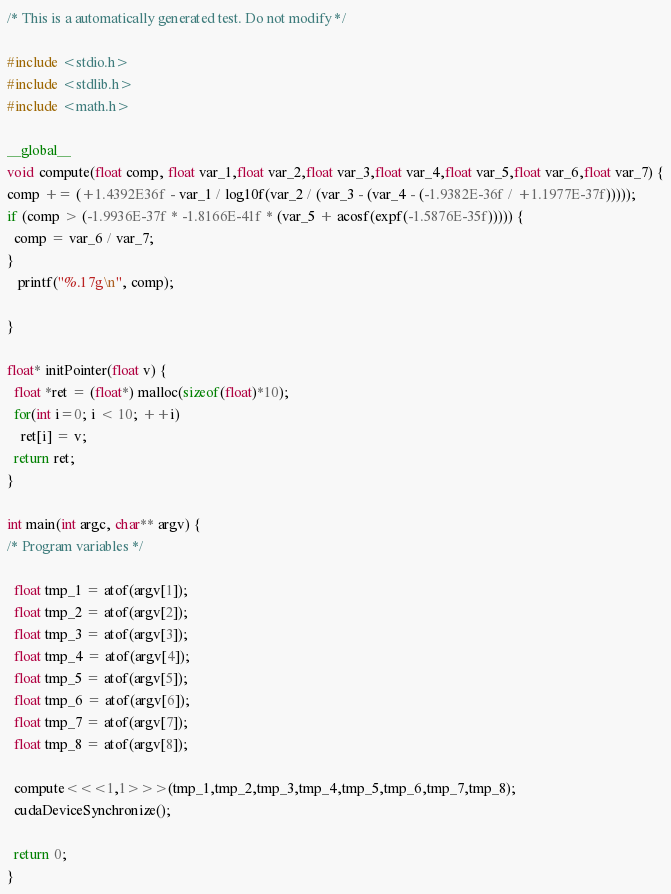Convert code to text. <code><loc_0><loc_0><loc_500><loc_500><_Cuda_>
/* This is a automatically generated test. Do not modify */

#include <stdio.h>
#include <stdlib.h>
#include <math.h>

__global__
void compute(float comp, float var_1,float var_2,float var_3,float var_4,float var_5,float var_6,float var_7) {
comp += (+1.4392E36f - var_1 / log10f(var_2 / (var_3 - (var_4 - (-1.9382E-36f / +1.1977E-37f)))));
if (comp > (-1.9936E-37f * -1.8166E-41f * (var_5 + acosf(expf(-1.5876E-35f))))) {
  comp = var_6 / var_7;
}
   printf("%.17g\n", comp);

}

float* initPointer(float v) {
  float *ret = (float*) malloc(sizeof(float)*10);
  for(int i=0; i < 10; ++i)
    ret[i] = v;
  return ret;
}

int main(int argc, char** argv) {
/* Program variables */

  float tmp_1 = atof(argv[1]);
  float tmp_2 = atof(argv[2]);
  float tmp_3 = atof(argv[3]);
  float tmp_4 = atof(argv[4]);
  float tmp_5 = atof(argv[5]);
  float tmp_6 = atof(argv[6]);
  float tmp_7 = atof(argv[7]);
  float tmp_8 = atof(argv[8]);

  compute<<<1,1>>>(tmp_1,tmp_2,tmp_3,tmp_4,tmp_5,tmp_6,tmp_7,tmp_8);
  cudaDeviceSynchronize();

  return 0;
}
</code> 